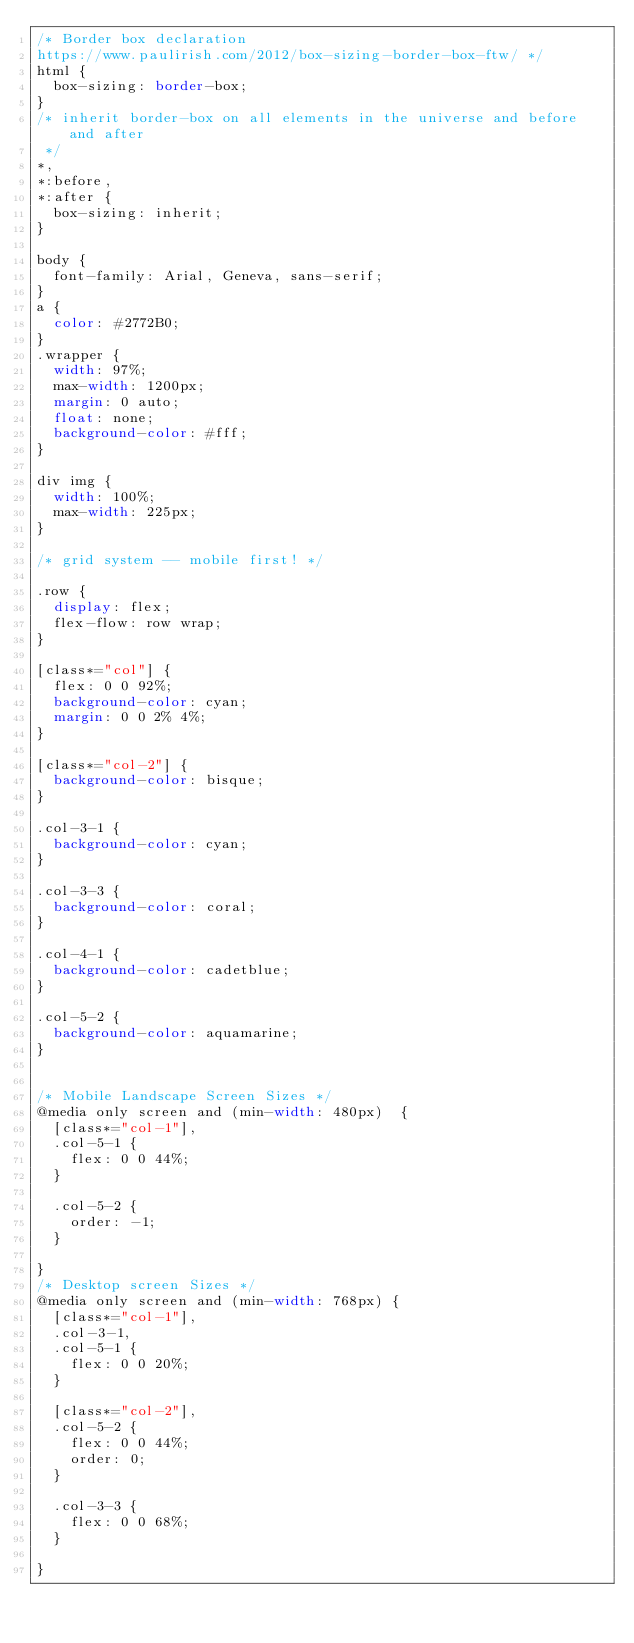Convert code to text. <code><loc_0><loc_0><loc_500><loc_500><_CSS_>/* Border box declaration 
https://www.paulirish.com/2012/box-sizing-border-box-ftw/ */
html {
  box-sizing: border-box;
}
/* inherit border-box on all elements in the universe and before and after
 */
*, 
*:before, 
*:after {
  box-sizing: inherit;
}

body {
	font-family: Arial, Geneva, sans-serif;
}
a {
	color: #2772B0;
}
.wrapper {
	width: 97%;
	max-width: 1200px;
	margin: 0 auto;
	float: none;
	background-color: #fff;
}

div img {
	width: 100%;
	max-width: 225px; 
}

/* grid system -- mobile first! */

.row {
	display: flex;
	flex-flow: row wrap;
}

[class*="col"] {
	flex: 0 0 92%;
	background-color: cyan;
	margin: 0 0 2% 4%;
}

[class*="col-2"] {
	background-color: bisque;
}

.col-3-1 {
	background-color: cyan;
}

.col-3-3 {
	background-color: coral;
}

.col-4-1 {
	background-color: cadetblue;
}

.col-5-2 {
	background-color: aquamarine;
}


/* Mobile Landscape Screen Sizes */
@media only screen and (min-width: 480px)  {
	[class*="col-1"],
	.col-5-1 {
		flex: 0 0 44%;
	}

	.col-5-2 {
		order: -1;
	}

}
/* Desktop screen Sizes */
@media only screen and (min-width: 768px) {
	[class*="col-1"],
	.col-3-1,
	.col-5-1 {
		flex: 0 0 20%;
	}

	[class*="col-2"],
	.col-5-2 {
		flex: 0 0 44%;
		order: 0;
	}

	.col-3-3 {
		flex: 0 0 68%;
	}

}</code> 